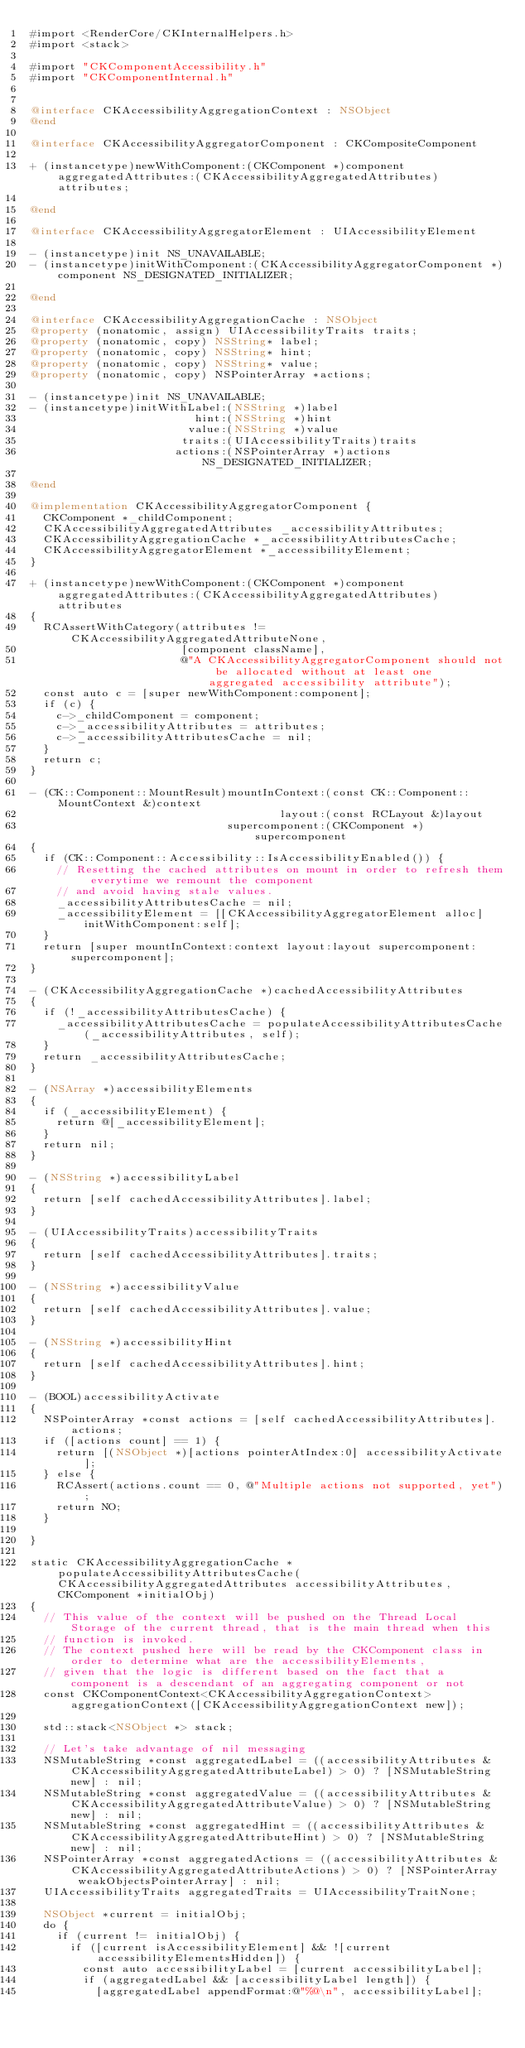<code> <loc_0><loc_0><loc_500><loc_500><_ObjectiveC_>#import <RenderCore/CKInternalHelpers.h>
#import <stack>

#import "CKComponentAccessibility.h"
#import "CKComponentInternal.h"


@interface CKAccessibilityAggregationContext : NSObject
@end

@interface CKAccessibilityAggregatorComponent : CKCompositeComponent

+ (instancetype)newWithComponent:(CKComponent *)component aggregatedAttributes:(CKAccessibilityAggregatedAttributes)attributes;

@end

@interface CKAccessibilityAggregatorElement : UIAccessibilityElement

- (instancetype)init NS_UNAVAILABLE;
- (instancetype)initWithComponent:(CKAccessibilityAggregatorComponent *)component NS_DESIGNATED_INITIALIZER;

@end

@interface CKAccessibilityAggregationCache : NSObject
@property (nonatomic, assign) UIAccessibilityTraits traits;
@property (nonatomic, copy) NSString* label;
@property (nonatomic, copy) NSString* hint;
@property (nonatomic, copy) NSString* value;
@property (nonatomic, copy) NSPointerArray *actions;

- (instancetype)init NS_UNAVAILABLE;
- (instancetype)initWithLabel:(NSString *)label
                         hint:(NSString *)hint
                        value:(NSString *)value
                       traits:(UIAccessibilityTraits)traits
                      actions:(NSPointerArray *)actions NS_DESIGNATED_INITIALIZER;

@end

@implementation CKAccessibilityAggregatorComponent {
  CKComponent *_childComponent;
  CKAccessibilityAggregatedAttributes _accessibilityAttributes;
  CKAccessibilityAggregationCache *_accessibilityAttributesCache;
  CKAccessibilityAggregatorElement *_accessibilityElement;
}

+ (instancetype)newWithComponent:(CKComponent *)component aggregatedAttributes:(CKAccessibilityAggregatedAttributes)attributes
{
  RCAssertWithCategory(attributes != CKAccessibilityAggregatedAttributeNone,
                       [component className],
                       @"A CKAccessibilityAggregatorComponent should not be allocated without at least one aggregated accessibility attribute");
  const auto c = [super newWithComponent:component];
  if (c) {
    c->_childComponent = component;
    c->_accessibilityAttributes = attributes;
    c->_accessibilityAttributesCache = nil;
  }
  return c;
}

- (CK::Component::MountResult)mountInContext:(const CK::Component::MountContext &)context
                                      layout:(const RCLayout &)layout
                              supercomponent:(CKComponent *)supercomponent
{
  if (CK::Component::Accessibility::IsAccessibilityEnabled()) {
    // Resetting the cached attributes on mount in order to refresh them everytime we remount the component
    // and avoid having stale values.
    _accessibilityAttributesCache = nil;
    _accessibilityElement = [[CKAccessibilityAggregatorElement alloc] initWithComponent:self];
  }
  return [super mountInContext:context layout:layout supercomponent:supercomponent];
}

- (CKAccessibilityAggregationCache *)cachedAccessibilityAttributes
{
  if (!_accessibilityAttributesCache) {
    _accessibilityAttributesCache = populateAccessibilityAttributesCache(_accessibilityAttributes, self);
  }
  return _accessibilityAttributesCache;
}

- (NSArray *)accessibilityElements
{
  if (_accessibilityElement) {
    return @[_accessibilityElement];
  }
  return nil;
}

- (NSString *)accessibilityLabel
{
  return [self cachedAccessibilityAttributes].label;
}

- (UIAccessibilityTraits)accessibilityTraits
{
  return [self cachedAccessibilityAttributes].traits;
}

- (NSString *)accessibilityValue
{
  return [self cachedAccessibilityAttributes].value;
}

- (NSString *)accessibilityHint
{
  return [self cachedAccessibilityAttributes].hint;
}

- (BOOL)accessibilityActivate
{
  NSPointerArray *const actions = [self cachedAccessibilityAttributes].actions;
  if ([actions count] == 1) {
    return [(NSObject *)[actions pointerAtIndex:0] accessibilityActivate];
  } else {
    RCAssert(actions.count == 0, @"Multiple actions not supported, yet");
    return NO;
  }

}

static CKAccessibilityAggregationCache *populateAccessibilityAttributesCache(CKAccessibilityAggregatedAttributes accessibilityAttributes, CKComponent *initialObj)
{
  // This value of the context will be pushed on the Thread Local Storage of the current thread, that is the main thread when this
  // function is invoked.
  // The context pushed here will be read by the CKComponent class in order to determine what are the accessibilityElements,
  // given that the logic is different based on the fact that a component is a descendant of an aggregating component or not
  const CKComponentContext<CKAccessibilityAggregationContext> aggregationContext([CKAccessibilityAggregationContext new]);

  std::stack<NSObject *> stack;

  // Let's take advantage of nil messaging
  NSMutableString *const aggregatedLabel = ((accessibilityAttributes & CKAccessibilityAggregatedAttributeLabel) > 0) ? [NSMutableString new] : nil;
  NSMutableString *const aggregatedValue = ((accessibilityAttributes & CKAccessibilityAggregatedAttributeValue) > 0) ? [NSMutableString new] : nil;
  NSMutableString *const aggregatedHint = ((accessibilityAttributes & CKAccessibilityAggregatedAttributeHint) > 0) ? [NSMutableString new] : nil;
  NSPointerArray *const aggregatedActions = ((accessibilityAttributes & CKAccessibilityAggregatedAttributeActions) > 0) ? [NSPointerArray weakObjectsPointerArray] : nil;
  UIAccessibilityTraits aggregatedTraits = UIAccessibilityTraitNone;

  NSObject *current = initialObj;
  do {
    if (current != initialObj) {
      if ([current isAccessibilityElement] && ![current accessibilityElementsHidden]) {
        const auto accessibilityLabel = [current accessibilityLabel];
        if (aggregatedLabel && [accessibilityLabel length]) {
          [aggregatedLabel appendFormat:@"%@\n", accessibilityLabel];</code> 